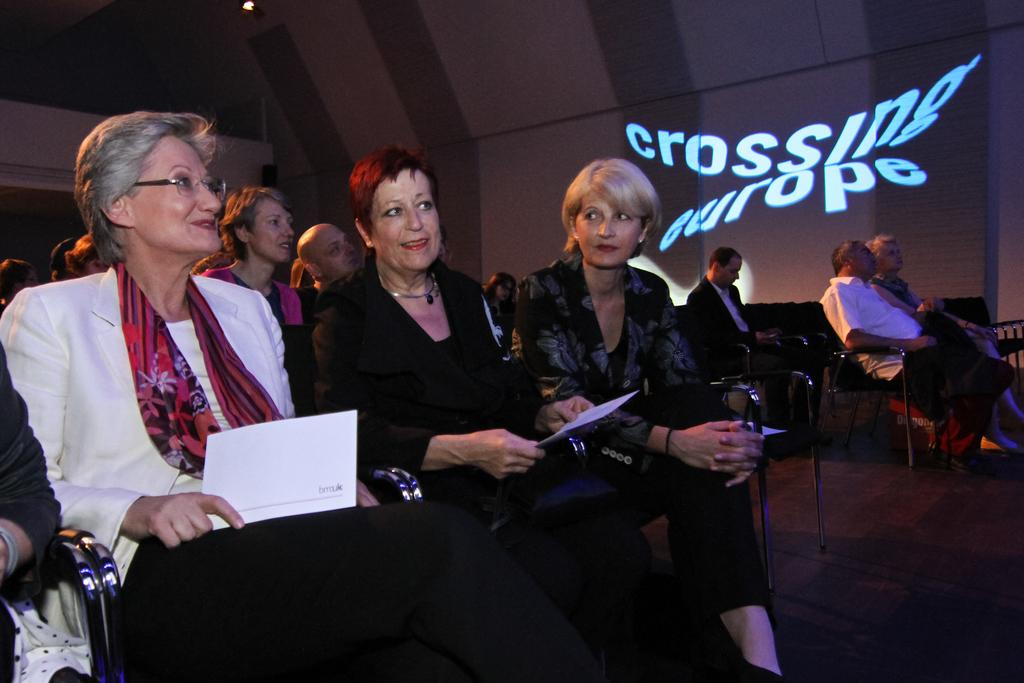How many people are in the image? There is a group of persons in the image. What are the persons doing in the image? The persons are sitting on chairs and smiling. What are the persons holding in their hands? The persons are holding papers in their hands. Can you describe any background elements in the image? There is something written at the back, possibly referring to a sign or a background element. How many babies are in the image? There is no mention of babies in the image; it features a group of persons sitting on chairs and smiling. What type of sound can be heard coming from the geese in the image? There are no geese present in the image, so it's not possible to determine what, if any, sounds might be heard. 